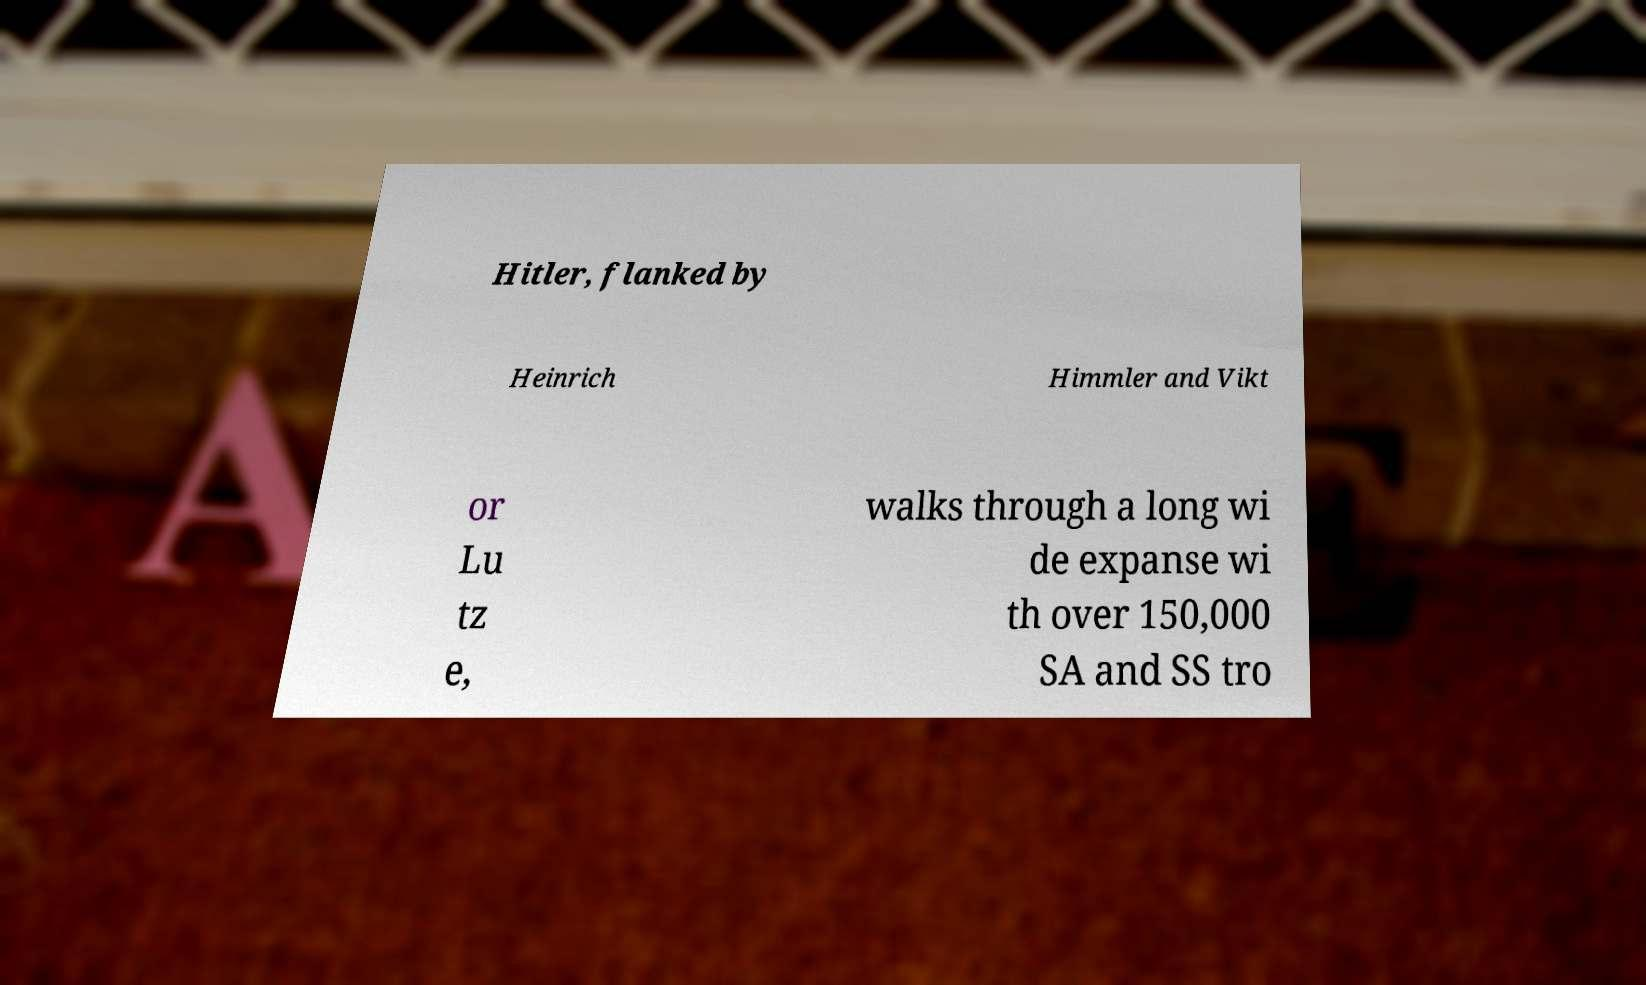Could you assist in decoding the text presented in this image and type it out clearly? Hitler, flanked by Heinrich Himmler and Vikt or Lu tz e, walks through a long wi de expanse wi th over 150,000 SA and SS tro 